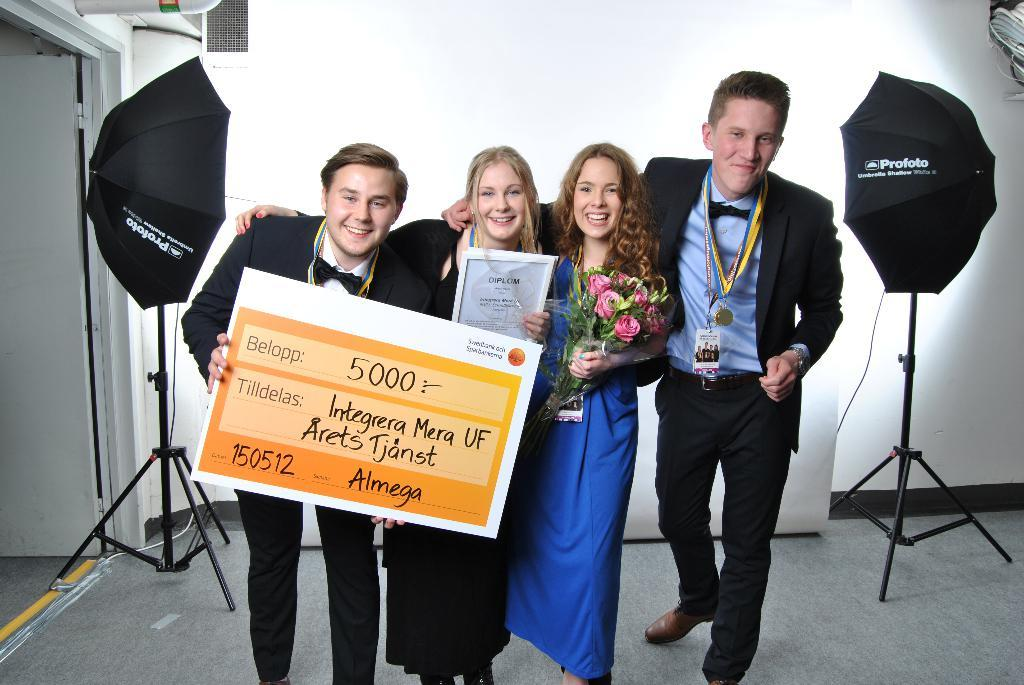How many people are in the image? There are people in the image, but the exact number is not specified. What is one person holding in the image? One person is holding a board in the image. What are the women holding in the image? One woman is holding a paper, and another woman is holding a flower bouquet. What can be seen in the image that might be used for protection from rain? There are umbrellas visible in the image. What type of care can be seen being provided to the baby in the image? There is no baby or care being provided in the image. How many matches are visible in the image? There are no matches present in the image. 